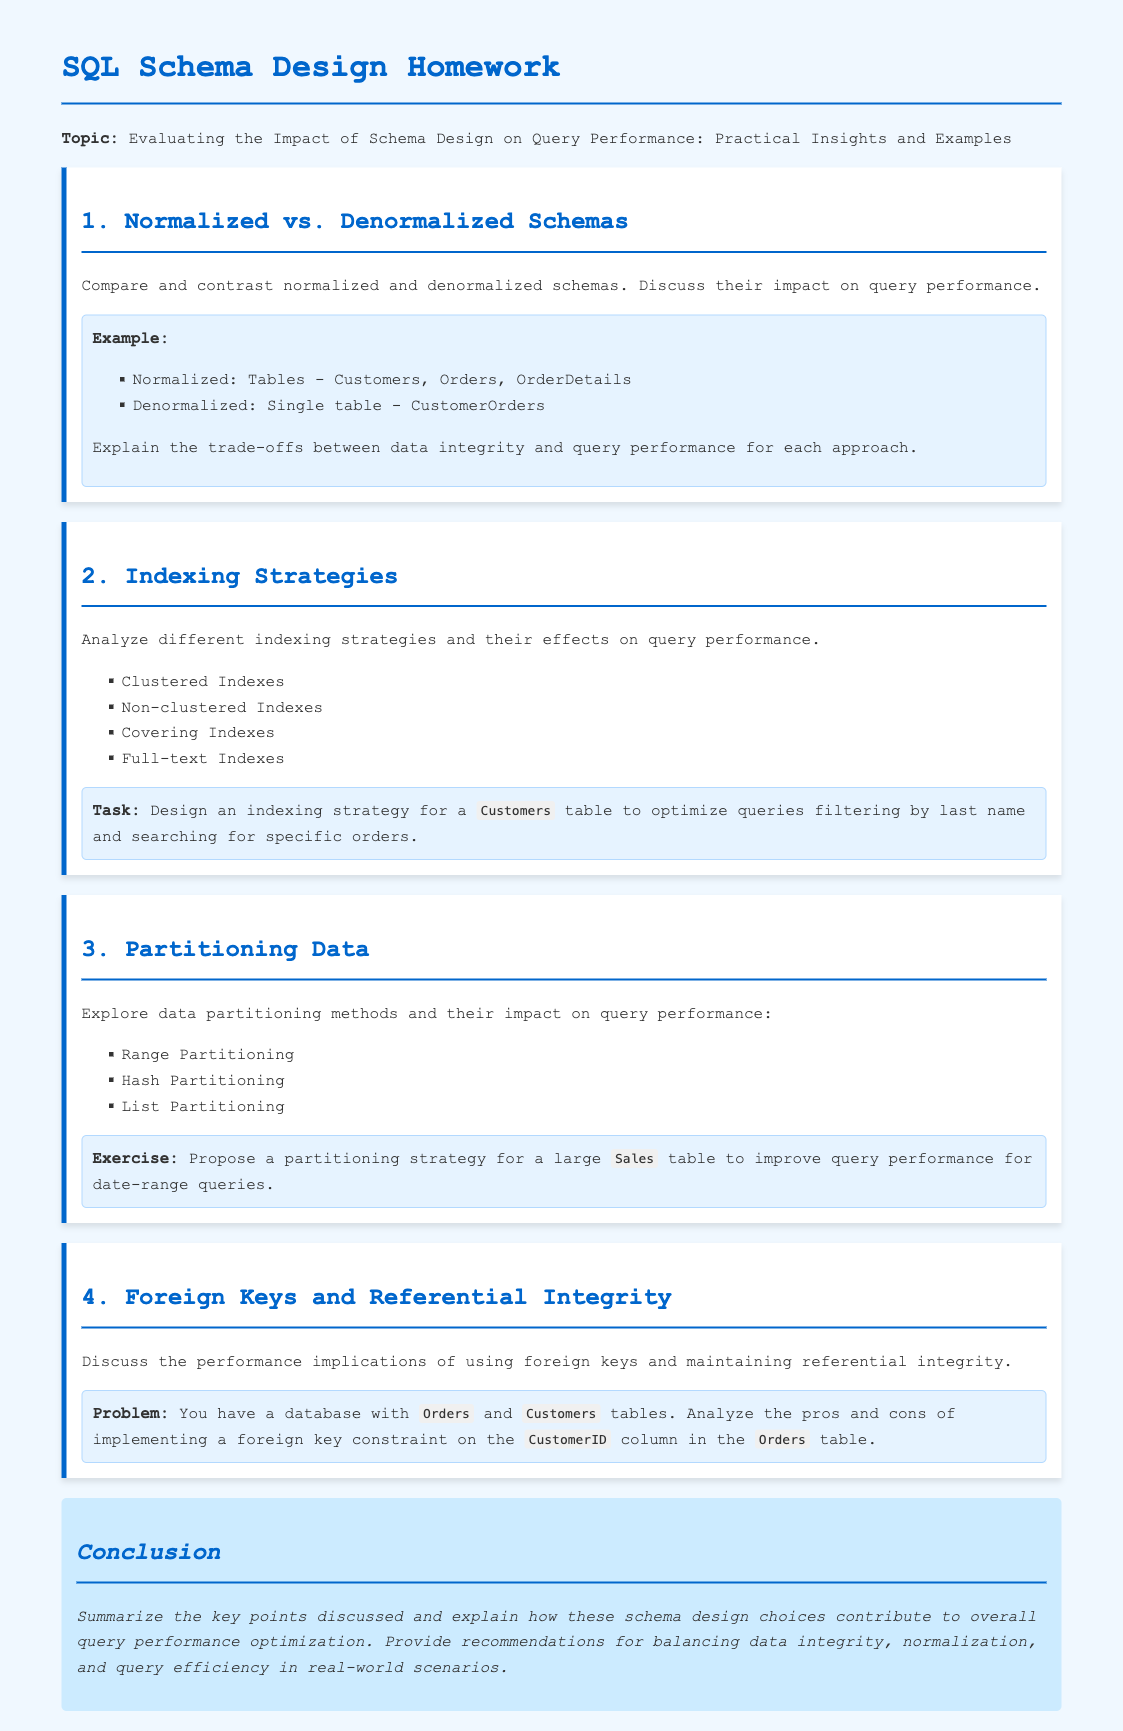What is the title of the homework? The title reveals the main topic of the document, which is about schema design and query performance.
Answer: SQL Schema Design Homework What are the two types of schemas compared in section 1? The document specifically discusses two types of schemas in the first section.
Answer: Normalized and Denormalized Name one indexing strategy mentioned in section 2. The document lists multiple indexing strategies in this section, which are essential for improving query performance.
Answer: Clustered Indexes What is a proposed partitioning method discussed in section 3? This method aims to improve query performance and is explicitly mentioned in the browsing section.
Answer: Range Partitioning What is the problem presented in section 4? The query examines the performance implications of foreign keys, particularly related to specific tables mentioned within the document.
Answer: Analyze the pros and cons How many examples are provided in the document? The number of examples assists in understanding the practical applications discussed.
Answer: Four What color is used for the headings throughout the document? The color coding of headings can impact the readability and design of the document.
Answer: Blue What type of constraint is analyzed in the foreign keys section? Understanding the type of constraint offers insight into the referential integrity discussions.
Answer: Foreign Key Constraint What is the focus of the conclusion section? The conclusion summarizes various discussions and provides recommendations relevant to the whole document.
Answer: Key points and recommendations 